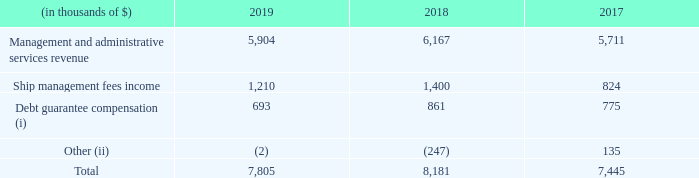B) transactions with golar power and affiliates:
net revenues: the transactions with golar power and its affiliates for the twelve months ended december 31, 2019, 2018 and 2017 consisted of the following:
(i) debt guarantee compensation - in connection with the closing of the golar power and stonepeak transaction, golar power entered into agreements to compensate golar in relation to certain debt guarantees (as further described under the subheading "guarantees and other") relating to golar power and subsidiaries.
(ii) balances due to golar power and affiliates - receivables and payables with golar power and its subsidiaries are comprised primarily of unpaid management fees, advisory and administrative services. in addition, certain receivables and payables arise when we pay an invoice on behalf of a related party and vice versa. receivables and payables are generally settled quarterly in arrears. balances owing to or due from golar power and its subsidiaries are unsecured, interest-free and intended to be settled in the ordinary course of business. in december 2019, we loaned $7.0 million to golar power, with interest of libor plus 5.0%. the loan was fully repaid, including interest, in december 2019.
with which party did golar power closed their transaction with? Stonepeak. In which years was the transactions recorded for? 2019, 2018, 2017. What do Receivables and payables with Golar Power and its subsidiaries consist of? Comprised primarily of unpaid management fees, advisory and administrative services. Which year was the debt guarantee compensation the lowest? 693 < 775 < 861
Answer: 2019. What was the change in ship management fees income from 2017 to 2018?
Answer scale should be: thousand. 1,400 - 824 
Answer: 576. What was the percentage change in total transactions from 2018 to 2019?
Answer scale should be: percent. (7,805 - 8,181)/8,181 
Answer: -4.6. 